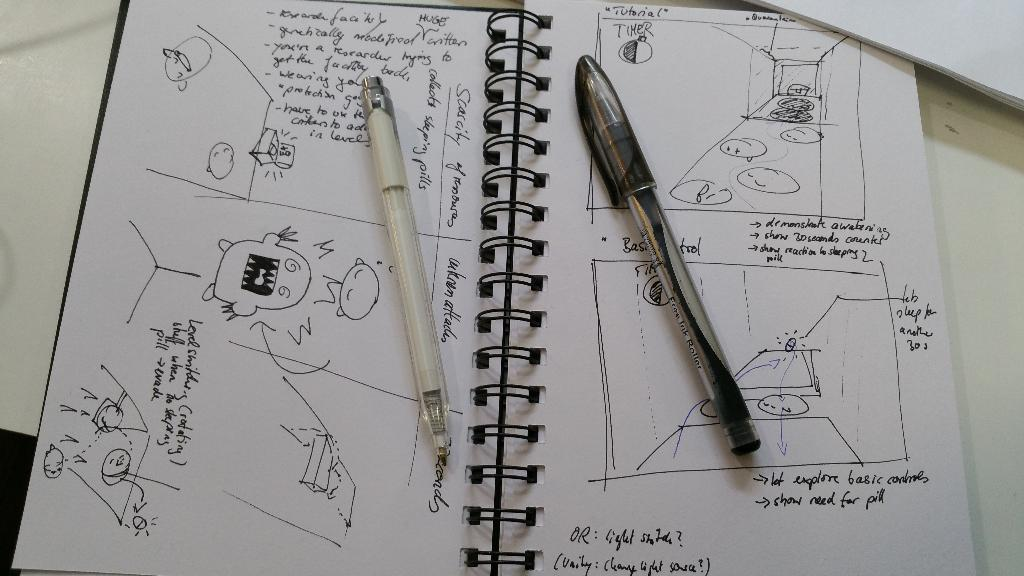What type of book is on the white surface in the image? There is a spiral book on the white surface in the image. What can be seen on the spiral book? There is writing and drawings visible on the spiral book. What are the pens used for in the image? The two pens are placed on the spiral book, likely for writing or drawing. What else is present in the image besides the spiral book and pens? White papers are present in the image. Can you tell me how many giraffes are visible in the image? There are no giraffes present in the image; it features a spiral book, pens, and white papers. What is the root of the spiral book in the image? There is no root associated with the spiral book in the image, as it is a stationary object on a white surface. 